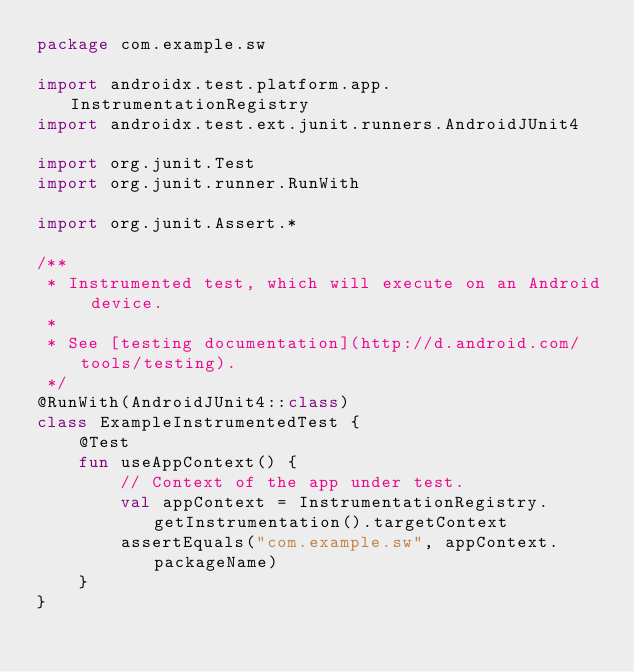Convert code to text. <code><loc_0><loc_0><loc_500><loc_500><_Kotlin_>package com.example.sw

import androidx.test.platform.app.InstrumentationRegistry
import androidx.test.ext.junit.runners.AndroidJUnit4

import org.junit.Test
import org.junit.runner.RunWith

import org.junit.Assert.*

/**
 * Instrumented test, which will execute on an Android device.
 *
 * See [testing documentation](http://d.android.com/tools/testing).
 */
@RunWith(AndroidJUnit4::class)
class ExampleInstrumentedTest {
    @Test
    fun useAppContext() {
        // Context of the app under test.
        val appContext = InstrumentationRegistry.getInstrumentation().targetContext
        assertEquals("com.example.sw", appContext.packageName)
    }
}</code> 